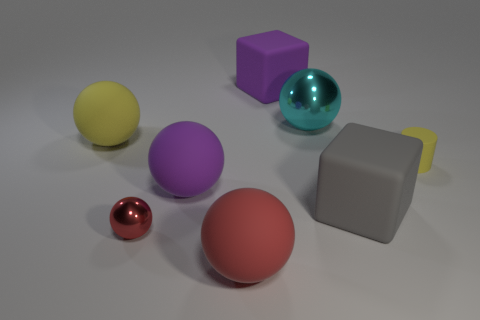There is a large sphere that is the same color as the matte cylinder; what material is it?
Offer a terse response. Rubber. How many yellow matte objects are on the left side of the small thing that is behind the big gray rubber thing?
Your answer should be compact. 1. There is a small red thing; are there any metal things to the right of it?
Provide a succinct answer. Yes. The purple matte thing behind the yellow object that is on the left side of the large shiny sphere is what shape?
Your answer should be compact. Cube. Are there fewer large cyan metallic balls that are in front of the cyan metallic ball than tiny red shiny balls behind the yellow sphere?
Your response must be concise. No. The small metallic object that is the same shape as the big yellow thing is what color?
Your answer should be compact. Red. How many large objects are both in front of the purple block and behind the big gray thing?
Keep it short and to the point. 3. Are there more small red shiny spheres that are left of the yellow ball than large objects on the left side of the large cyan shiny ball?
Your answer should be compact. No. What size is the purple matte sphere?
Offer a very short reply. Large. Is there another big matte object of the same shape as the cyan object?
Provide a succinct answer. Yes. 